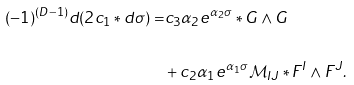Convert formula to latex. <formula><loc_0><loc_0><loc_500><loc_500>( - 1 ) ^ { ( D - 1 ) } d ( 2 c _ { 1 } \ast d \sigma ) = & c _ { 3 } \alpha _ { 2 } e ^ { \alpha _ { 2 } \sigma } \ast G \wedge G \\ \\ & + c _ { 2 } \alpha _ { 1 } e ^ { \alpha _ { 1 } \sigma } \mathcal { M } _ { I J } \ast F ^ { I } \wedge F ^ { J } .</formula> 